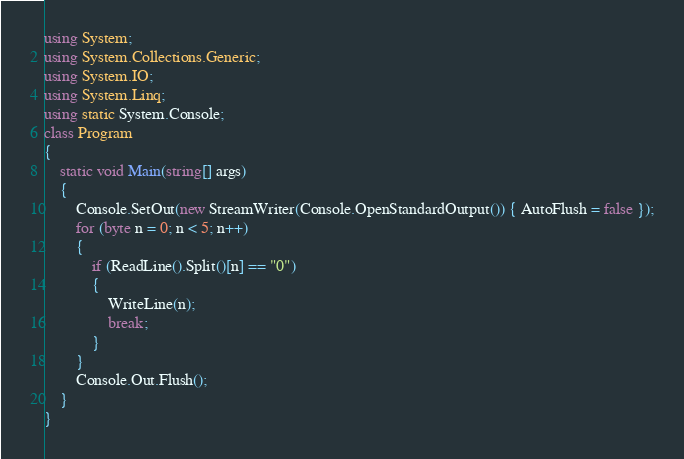<code> <loc_0><loc_0><loc_500><loc_500><_C#_>using System;
using System.Collections.Generic;
using System.IO;
using System.Linq;
using static System.Console;
class Program
{
    static void Main(string[] args)
    {
        Console.SetOut(new StreamWriter(Console.OpenStandardOutput()) { AutoFlush = false });
        for (byte n = 0; n < 5; n++)
        {
            if (ReadLine().Split()[n] == "0")
            {
                WriteLine(n);
                break;
            }
        }
        Console.Out.Flush();
    }
}</code> 